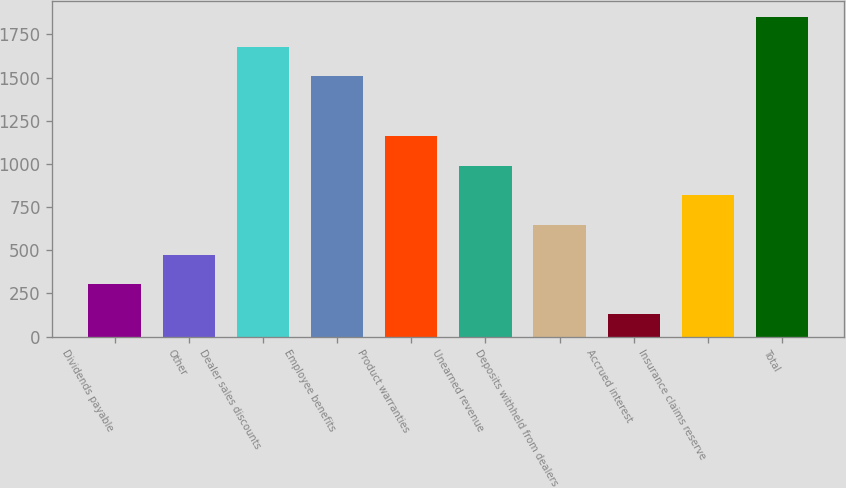Convert chart to OTSL. <chart><loc_0><loc_0><loc_500><loc_500><bar_chart><fcel>Dividends payable<fcel>Other<fcel>Dealer sales discounts<fcel>Employee benefits<fcel>Product warranties<fcel>Unearned revenue<fcel>Deposits withheld from dealers<fcel>Accrued interest<fcel>Insurance claims reserve<fcel>Total<nl><fcel>302<fcel>474<fcel>1678<fcel>1506<fcel>1162<fcel>990<fcel>646<fcel>130<fcel>818<fcel>1850<nl></chart> 